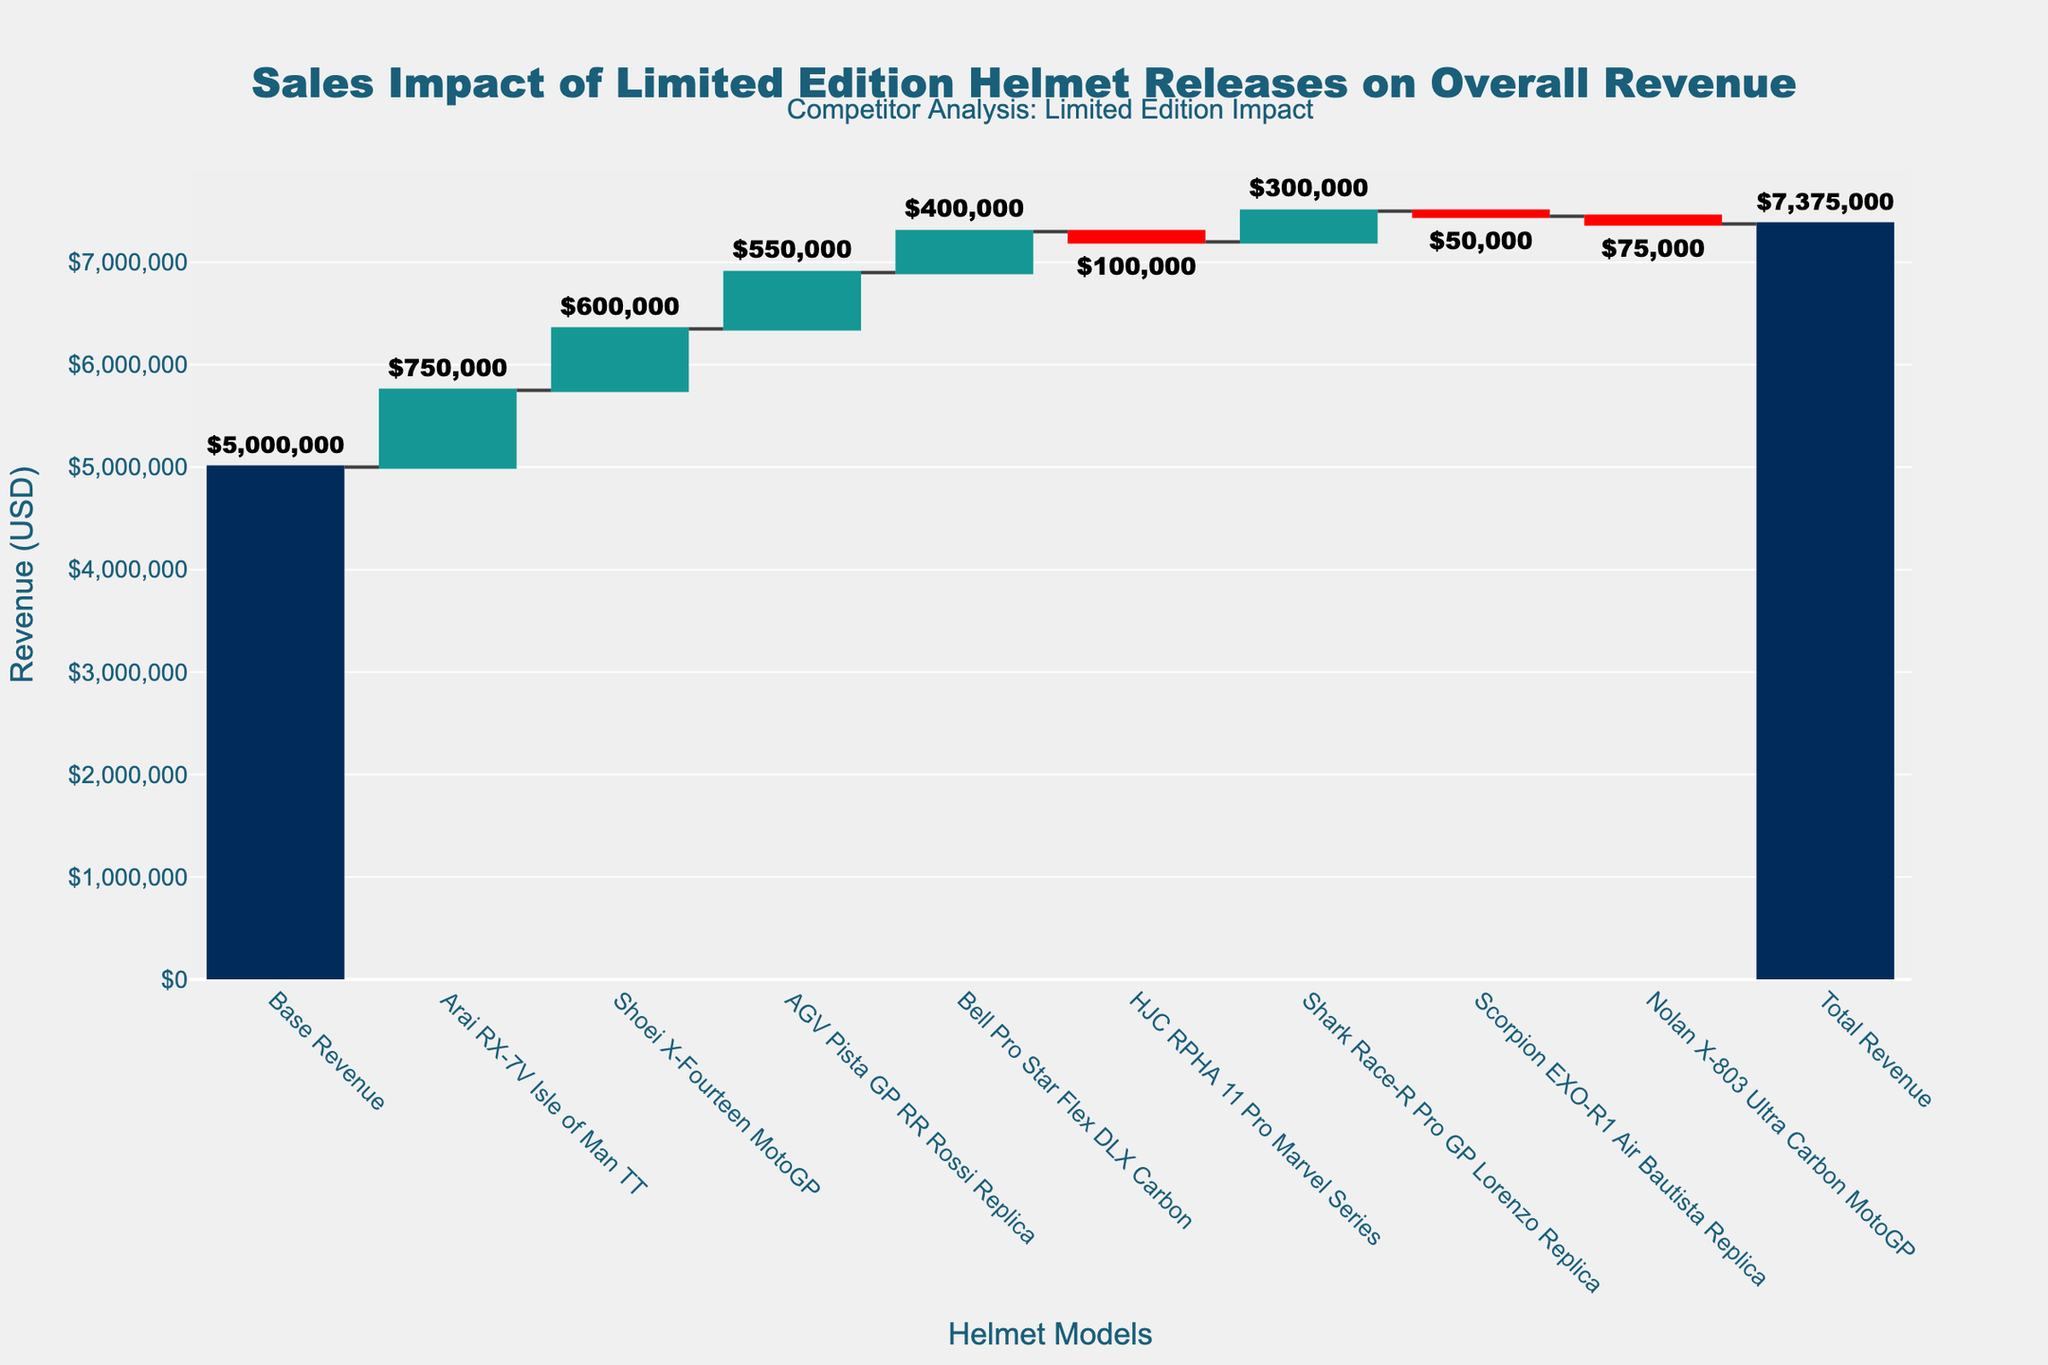What is the base revenue shown in the waterfall chart? The base revenue is displayed as the first bar on the left. The value indicated is $5,000,000.
Answer: $5,000,000 Which limited edition helmet had the highest positive impact on revenue? The height of each positive bar in the chart represents the revenue impact of each helmet. The "Arai RX-7V Isle of Man TT" helmet has the tallest positive bar, indicating an impact of $750,000.
Answer: Arai RX-7V Isle of Man TT How much did the "HJC RPHA 11 Pro Marvel Series" impact the revenue? This helmet has a negative impact visible as a red bar in the chart. The height of the bar indicates it reduced revenue by $100,000.
Answer: -$100,000 What's the overall revenue after considering all the helmet releases? The final bar on the right shows the total revenue after all impacts. The value indicated is $7,375,000.
Answer: $7,375,000 What is the combined revenue impact of the "Scorpion EXO-R1 Air Bautista Replica" and "Nolan X-803 Ultra Carbon MotoGP"? Both helmets have negative impacts on revenue. Their combined impact is calculated by summing their values: -$50,000 + -$75,000 = -$125,000.
Answer: -$125,000 Which limited edition helmet contributed the least to revenue, and how much was it? The "Nolan X-803 Ultra Carbon MotoGP" has the smallest positive or largest negative impact, seen as the shortest red bar, with a value of -$75,000.
Answer: Nolan X-803 Ultra Carbon MotoGP, -$75,000 How many limited edition helmets had a negative impact on revenue? By counting the red bars in the waterfall chart, we see that three helmets had a negative impact: "HJC RPHA 11 Pro Marvel Series", "Scorpion EXO-R1 Air Bautista Replica", and "Nolan X-803 Ultra Carbon MotoGP".
Answer: 3 What is the total positive revenue impact brought by the top three best-selling limited edition helmets? The top three helmets with the highest positive impact are "Arai RX-7V Isle of Man TT" ($750,000), "Shoei X-Fourteen MotoGP" ($600,000), and "AGV Pista GP RR Rossi Replica" ($550,000). Their combined positive impact is $750,000 + $600,000 + $550,000 = $1,900,000.
Answer: $1,900,000 What is the average revenue impact of all helmets excluding the base and total revenue? First, sum the values of all helmets: $750,000 + $600,000 + $550,000 + $400,000 + -$100,000 + $300,000 + -$50,000 + -$75,000 = $2,375,000. There are 8 helmets, so the average impact is $2,375,000 / 8 = $296,875.
Answer: $296,875 